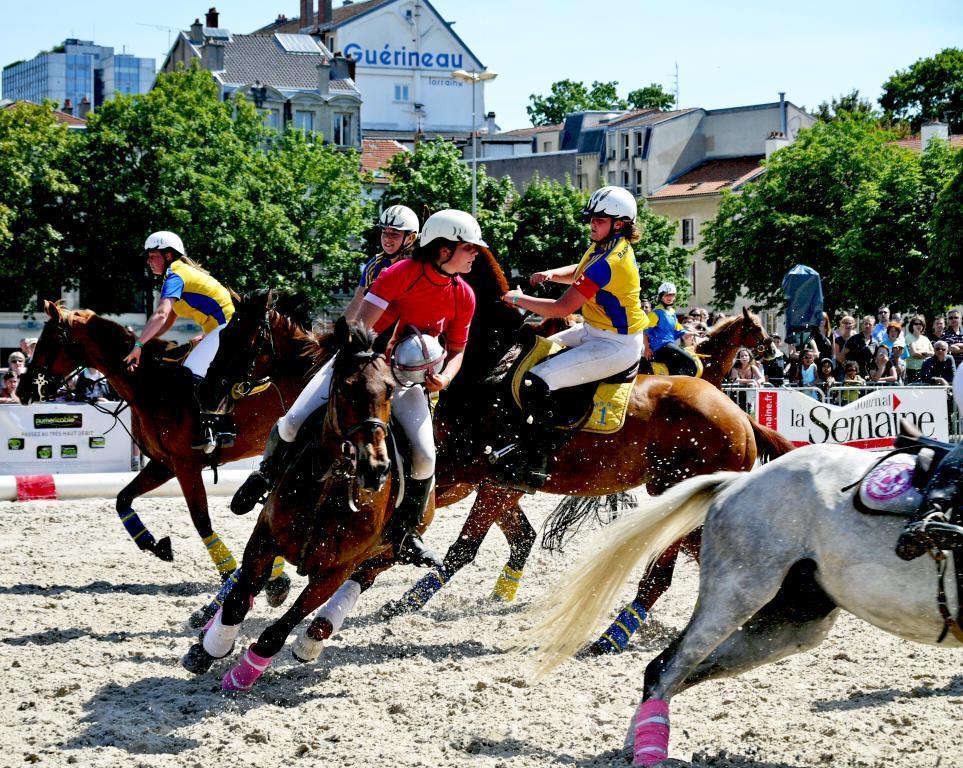Please provide a concise description of this image. In this Image I can see few people are sitting on the horses. Horse is in brown,black and white color. Back I can see buildings,windows,trees,light-poles,fencing and few people around. The sky is in white and blue color. 